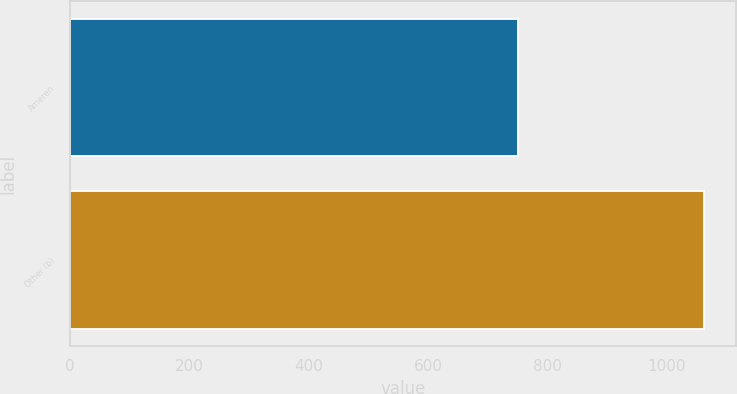<chart> <loc_0><loc_0><loc_500><loc_500><bar_chart><fcel>Ameren<fcel>Other (b)<nl><fcel>750<fcel>1062<nl></chart> 